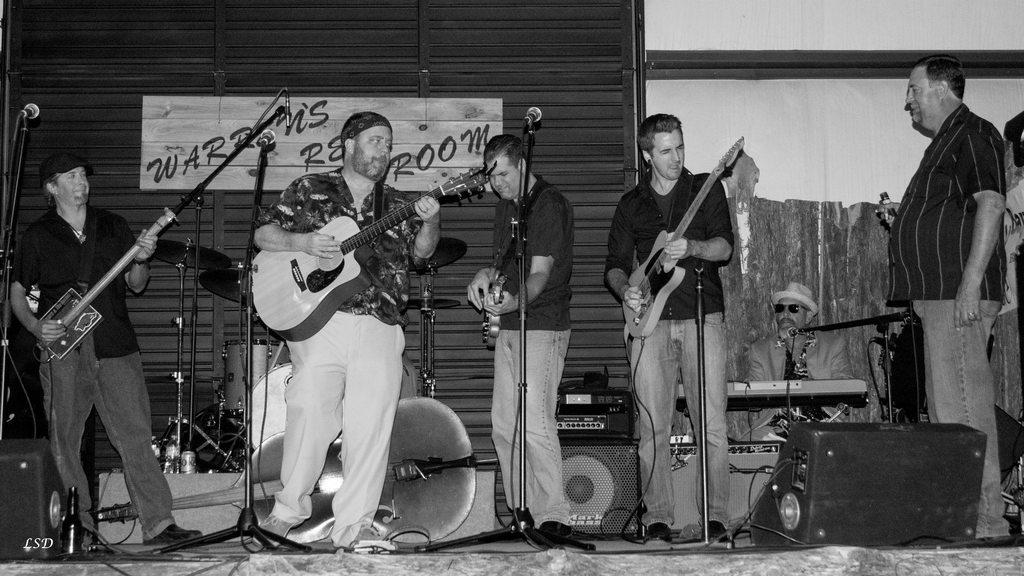Who or what can be seen in the image? There are people in the image. What are the people doing in the image? The people are standing and holding guitars in their hands. What is the color scheme of the image? The image is in black and white color. What type of discovery can be seen in the image? There is no discovery present in the image; it features people holding guitars. What details can be observed on the guitars in the image? The provided facts do not mention any specific details about the guitars, so we cannot answer this question definitively. 